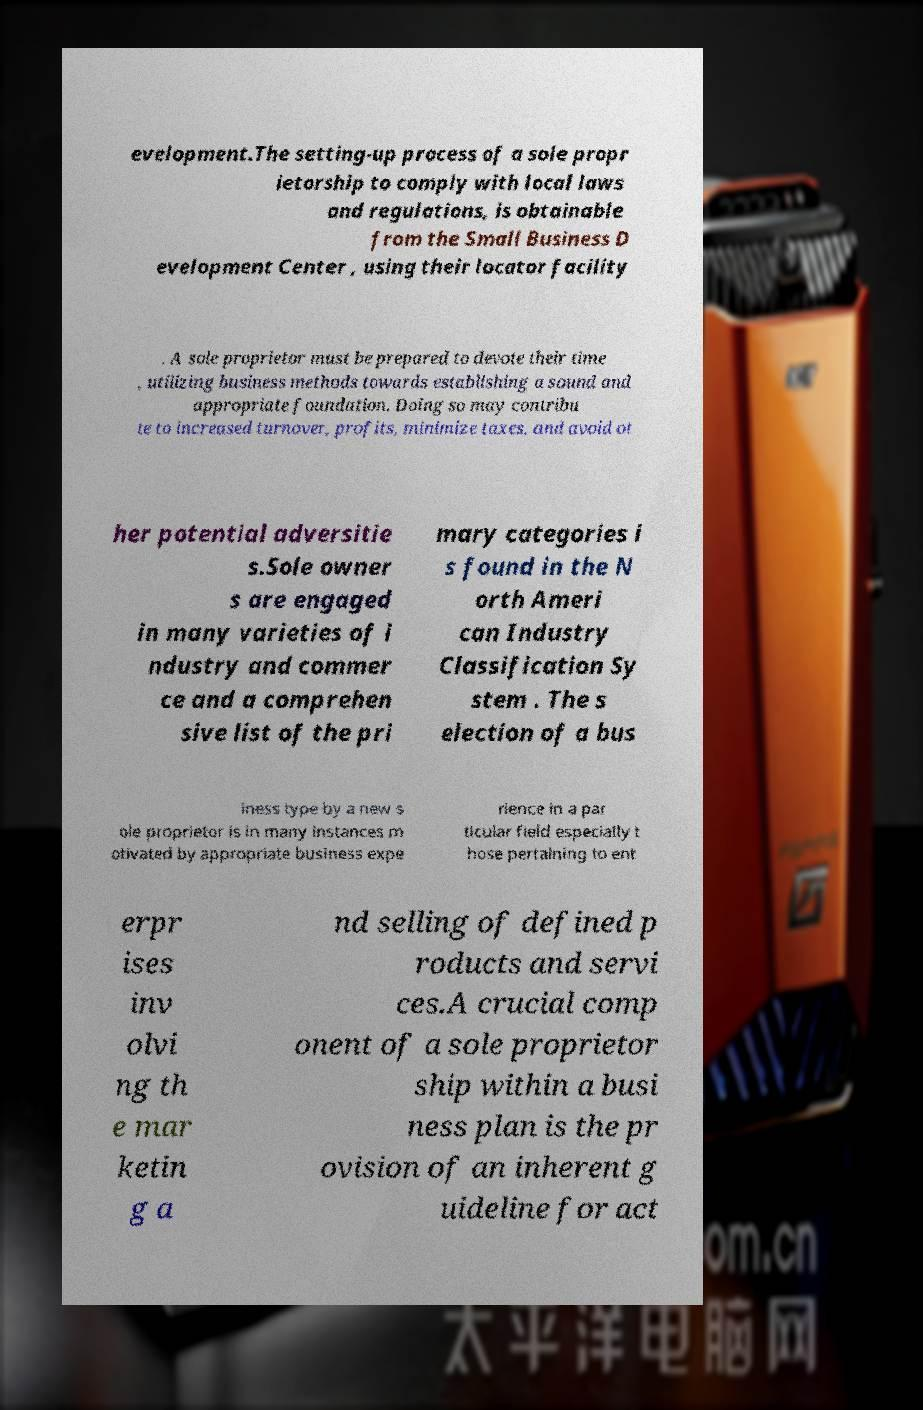Can you accurately transcribe the text from the provided image for me? evelopment.The setting-up process of a sole propr ietorship to comply with local laws and regulations, is obtainable from the Small Business D evelopment Center , using their locator facility . A sole proprietor must be prepared to devote their time , utilizing business methods towards establishing a sound and appropriate foundation. Doing so may contribu te to increased turnover, profits, minimize taxes, and avoid ot her potential adversitie s.Sole owner s are engaged in many varieties of i ndustry and commer ce and a comprehen sive list of the pri mary categories i s found in the N orth Ameri can Industry Classification Sy stem . The s election of a bus iness type by a new s ole proprietor is in many instances m otivated by appropriate business expe rience in a par ticular field especially t hose pertaining to ent erpr ises inv olvi ng th e mar ketin g a nd selling of defined p roducts and servi ces.A crucial comp onent of a sole proprietor ship within a busi ness plan is the pr ovision of an inherent g uideline for act 